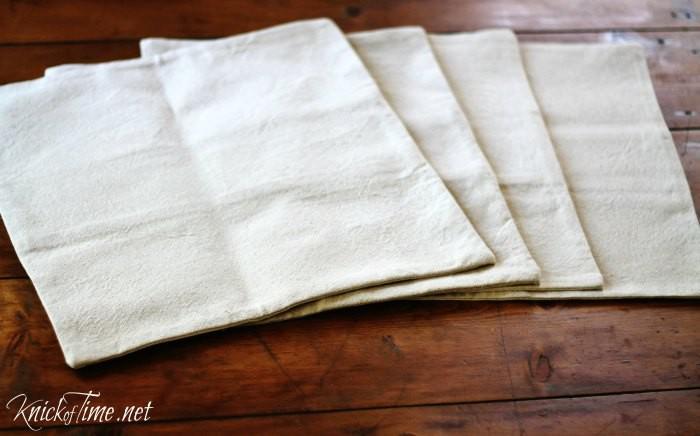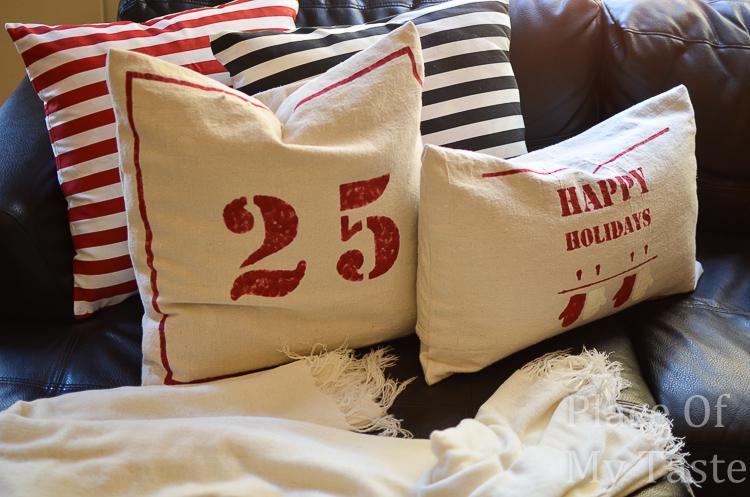The first image is the image on the left, the second image is the image on the right. Given the left and right images, does the statement "The righthand image includes striped pillows and a pillow with mitten pairs stamped on it." hold true? Answer yes or no. Yes. The first image is the image on the left, the second image is the image on the right. Assess this claim about the two images: "The right image contains at least four pillows.". Correct or not? Answer yes or no. Yes. 